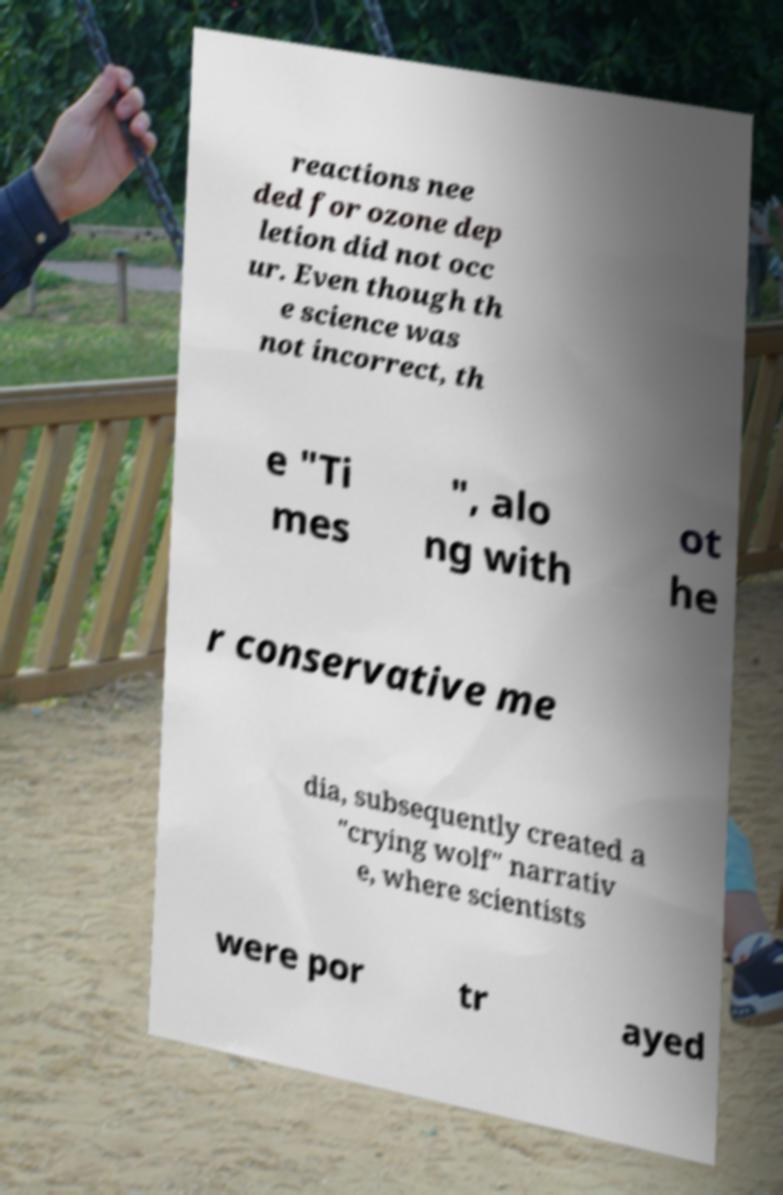Please read and relay the text visible in this image. What does it say? reactions nee ded for ozone dep letion did not occ ur. Even though th e science was not incorrect, th e "Ti mes ", alo ng with ot he r conservative me dia, subsequently created a "crying wolf" narrativ e, where scientists were por tr ayed 